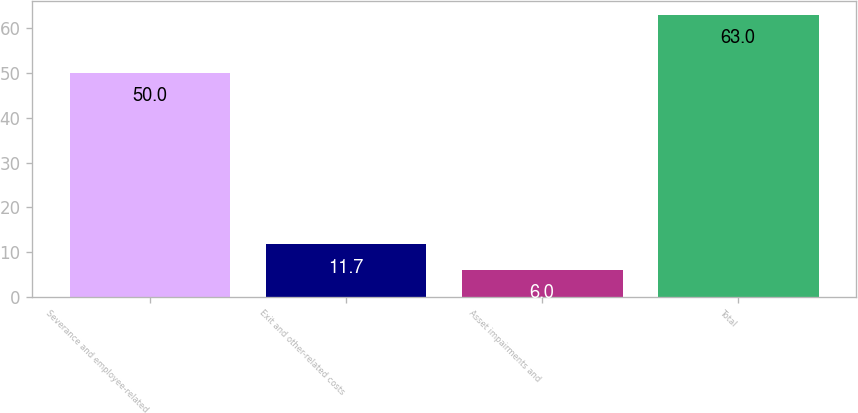Convert chart. <chart><loc_0><loc_0><loc_500><loc_500><bar_chart><fcel>Severance and employee-related<fcel>Exit and other-related costs<fcel>Asset impairments and<fcel>Total<nl><fcel>50<fcel>11.7<fcel>6<fcel>63<nl></chart> 